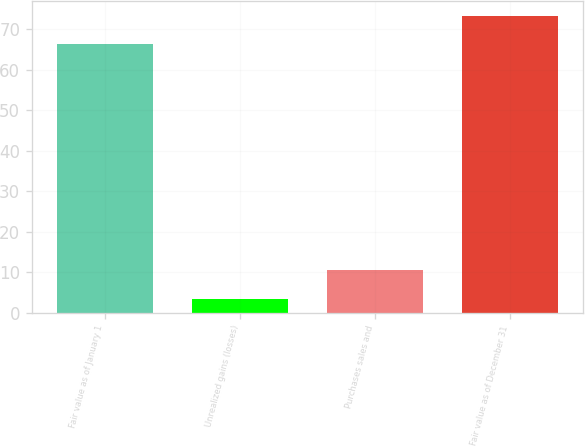Convert chart. <chart><loc_0><loc_0><loc_500><loc_500><bar_chart><fcel>Fair value as of January 1<fcel>Unrealized gains (losses)<fcel>Purchases sales and<fcel>Fair value as of December 31<nl><fcel>66.2<fcel>3.5<fcel>10.46<fcel>73.16<nl></chart> 